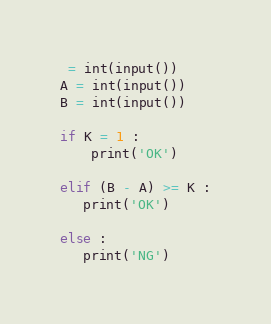<code> <loc_0><loc_0><loc_500><loc_500><_Python_> = int(input())
A = int(input())
B = int(input())

if K = 1 :
    print('OK')

elif (B - A) >= K :
   print('OK')

else :
   print('NG')</code> 